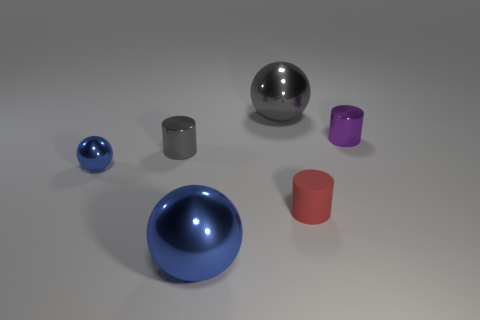What material is the blue thing to the left of the blue ball on the right side of the blue metallic ball to the left of the big blue sphere made of?
Keep it short and to the point. Metal. Is there a brown shiny block of the same size as the matte cylinder?
Ensure brevity in your answer.  No. What is the color of the small shiny cylinder in front of the metal cylinder to the right of the big gray object?
Make the answer very short. Gray. What number of tiny gray rubber cubes are there?
Your response must be concise. 0. Do the small ball and the rubber thing have the same color?
Keep it short and to the point. No. Are there fewer big gray metal objects on the right side of the small purple thing than metallic cylinders that are left of the gray ball?
Provide a succinct answer. Yes. The tiny ball is what color?
Provide a succinct answer. Blue. How many big spheres are the same color as the small rubber cylinder?
Provide a succinct answer. 0. There is a small matte object; are there any big gray metal objects in front of it?
Keep it short and to the point. No. Is the number of small red matte cylinders that are left of the big gray ball the same as the number of tiny gray cylinders in front of the small gray cylinder?
Offer a terse response. Yes. 